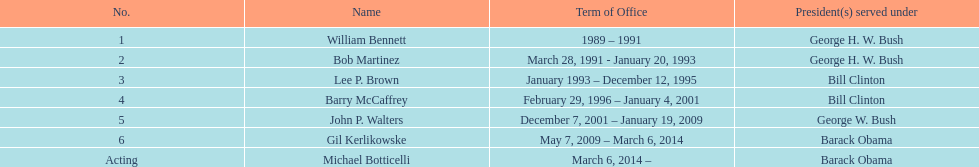What was the length of bob martinez's service as director? 2 years. 